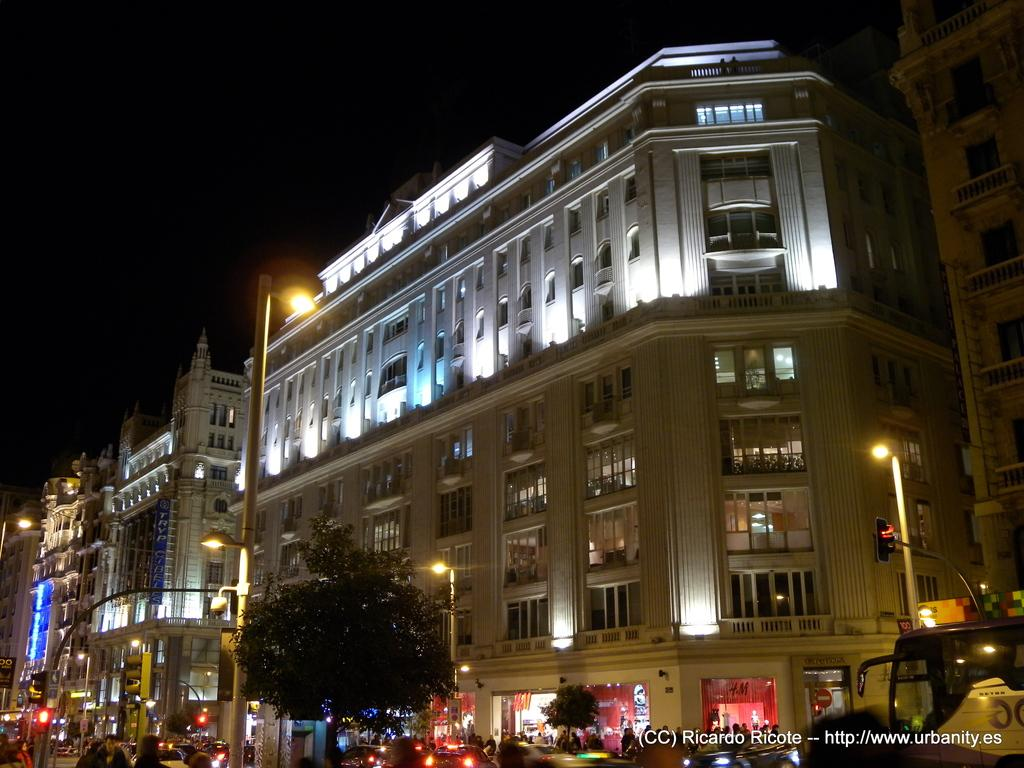What type of structures can be seen in the image? There are buildings in the image. What other natural elements are present in the image? There are trees in the image. What are the light poles used for in the image? The light poles are used for illumination in the image. Can you describe the people in the image? There are persons in the image. What type of traffic control devices are present in the image? There are traffic signals in the image. What else can be seen moving in the image? There are vehicles in the image. Where is the kitty playing with the wire in the image? There is no kitty or wire present in the image. What type of train can be seen passing through the buildings in the image? There is no train visible in the image; it only features buildings, trees, light poles, persons, traffic signals, and vehicles. 